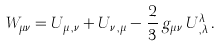Convert formula to latex. <formula><loc_0><loc_0><loc_500><loc_500>W _ { \mu \nu } = U _ { \mu \, , \nu } + U _ { \nu \, , \mu } - \frac { 2 } { 3 } \, g _ { \mu \nu } \, U ^ { \lambda } _ { \, , \lambda } \, .</formula> 